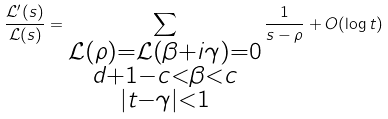Convert formula to latex. <formula><loc_0><loc_0><loc_500><loc_500>\frac { { \mathcal { L } } ^ { \prime } ( s ) } { { \mathcal { L } } ( s ) } = \sum _ { \substack { { \mathcal { L } } ( \rho ) = { \mathcal { L } } ( \beta + i \gamma ) = 0 \\ d + 1 - c < \beta < c \\ | t - \gamma | < 1 } } \frac { 1 } { s - \rho } + O ( \log { t } )</formula> 